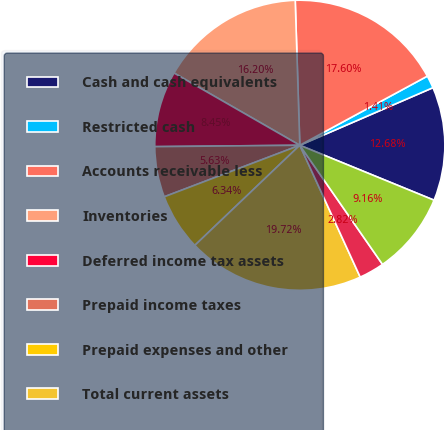Convert chart to OTSL. <chart><loc_0><loc_0><loc_500><loc_500><pie_chart><fcel>Cash and cash equivalents<fcel>Restricted cash<fcel>Accounts receivable less<fcel>Inventories<fcel>Deferred income tax assets<fcel>Prepaid income taxes<fcel>Prepaid expenses and other<fcel>Total current assets<fcel>Land<fcel>Buildings and improvements<nl><fcel>12.68%<fcel>1.41%<fcel>17.6%<fcel>16.2%<fcel>8.45%<fcel>5.63%<fcel>6.34%<fcel>19.72%<fcel>2.82%<fcel>9.16%<nl></chart> 